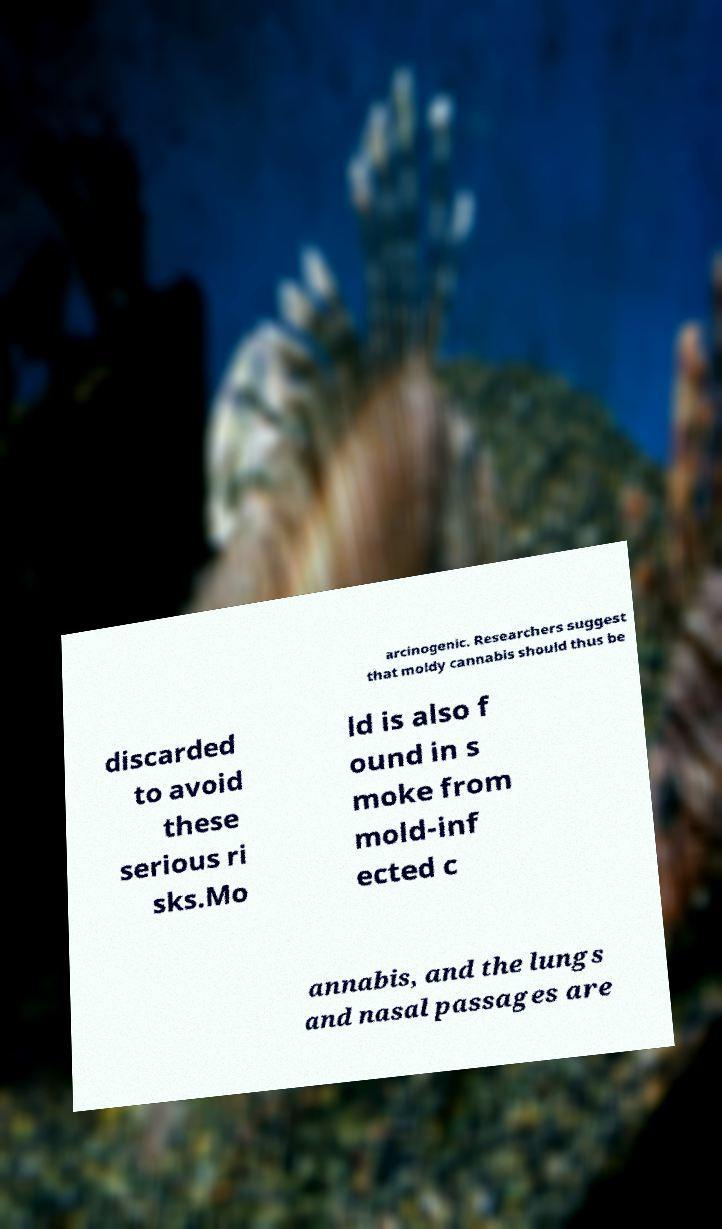There's text embedded in this image that I need extracted. Can you transcribe it verbatim? arcinogenic. Researchers suggest that moldy cannabis should thus be discarded to avoid these serious ri sks.Mo ld is also f ound in s moke from mold-inf ected c annabis, and the lungs and nasal passages are 